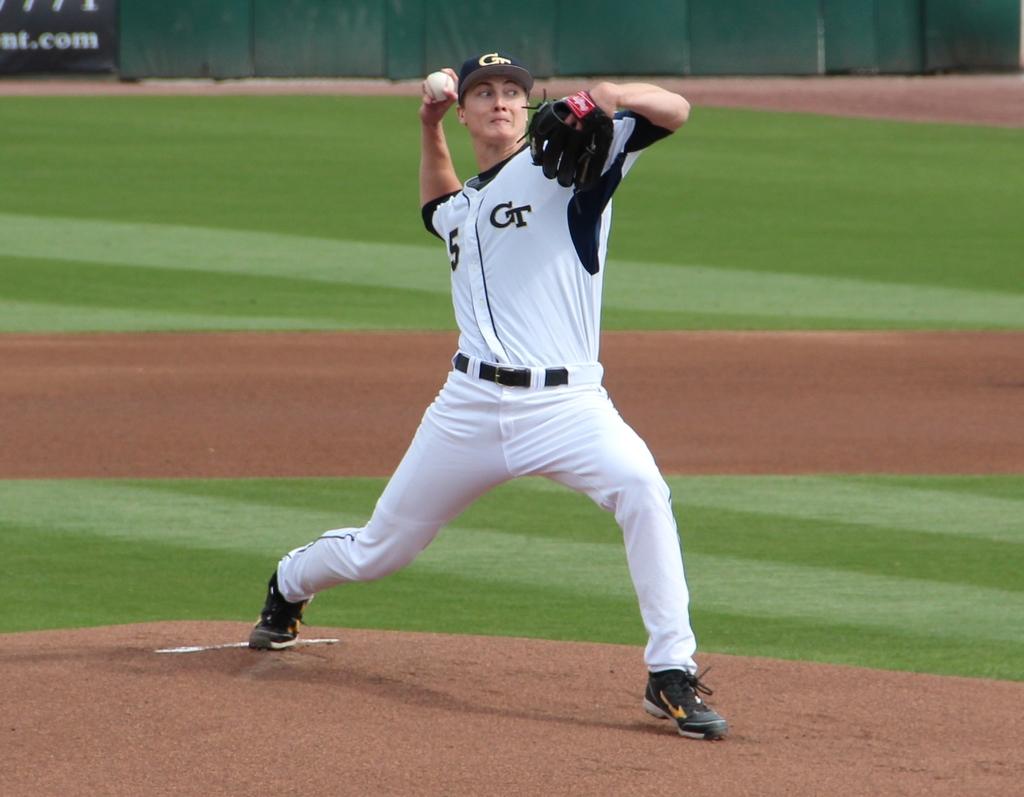What team is the player playing for ?
Offer a terse response. Ct. What number is the pitcher?
Offer a terse response. 5. 